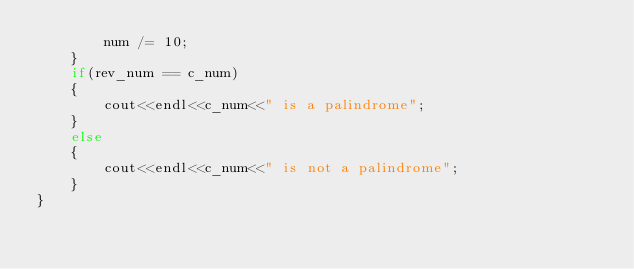Convert code to text. <code><loc_0><loc_0><loc_500><loc_500><_C++_>        num /= 10;
    }
    if(rev_num == c_num)
    {
        cout<<endl<<c_num<<" is a palindrome";
    }
    else
    {
        cout<<endl<<c_num<<" is not a palindrome";
    }
}
</code> 